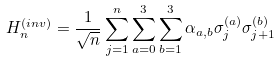<formula> <loc_0><loc_0><loc_500><loc_500>H _ { n } ^ { ( i n v ) } = \frac { 1 } { \sqrt { n } } \sum _ { j = 1 } ^ { n } \sum _ { a = 0 } ^ { 3 } \sum _ { b = 1 } ^ { 3 } \alpha _ { a , b } \sigma _ { j } ^ { ( a ) } \sigma _ { j + 1 } ^ { ( b ) }</formula> 